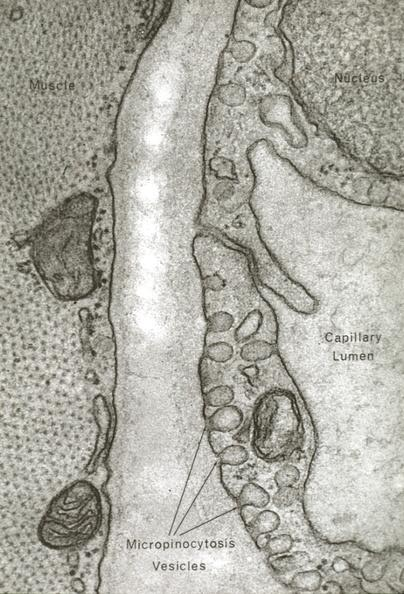s capillary present?
Answer the question using a single word or phrase. Yes 